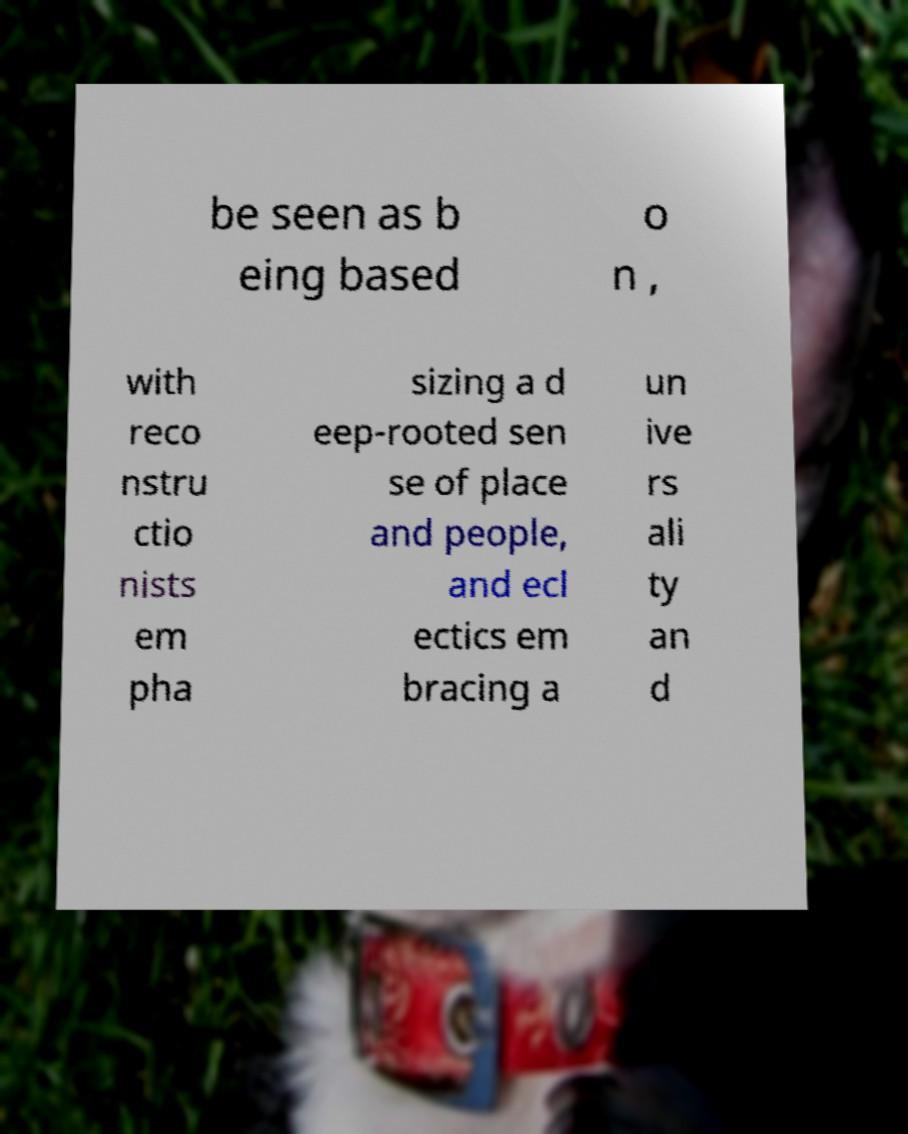I need the written content from this picture converted into text. Can you do that? be seen as b eing based o n , with reco nstru ctio nists em pha sizing a d eep-rooted sen se of place and people, and ecl ectics em bracing a un ive rs ali ty an d 